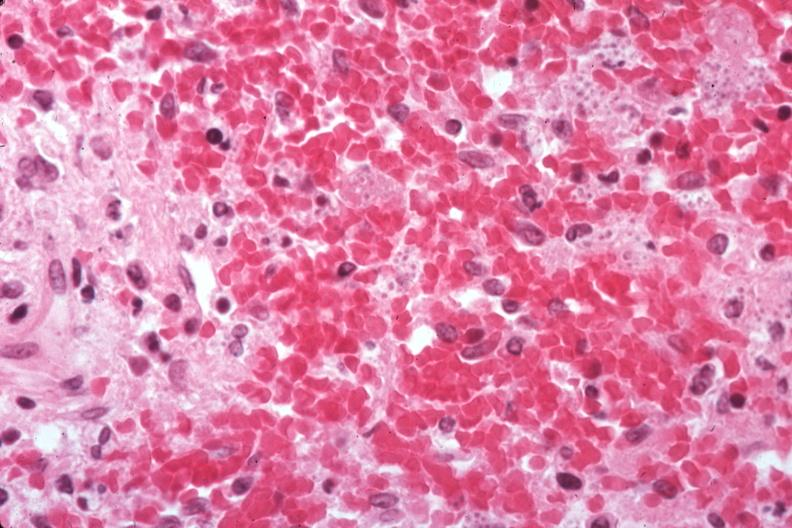s nodule present?
Answer the question using a single word or phrase. No 